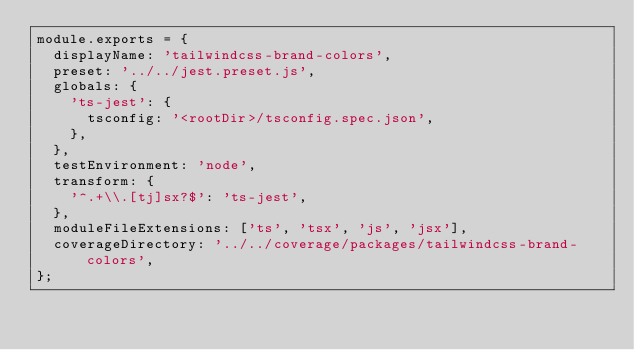Convert code to text. <code><loc_0><loc_0><loc_500><loc_500><_JavaScript_>module.exports = {
  displayName: 'tailwindcss-brand-colors',
  preset: '../../jest.preset.js',
  globals: {
    'ts-jest': {
      tsconfig: '<rootDir>/tsconfig.spec.json',
    },
  },
  testEnvironment: 'node',
  transform: {
    '^.+\\.[tj]sx?$': 'ts-jest',
  },
  moduleFileExtensions: ['ts', 'tsx', 'js', 'jsx'],
  coverageDirectory: '../../coverage/packages/tailwindcss-brand-colors',
};
</code> 